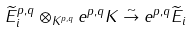Convert formula to latex. <formula><loc_0><loc_0><loc_500><loc_500>\widetilde { E } ^ { p , q } _ { i } \otimes _ { K ^ { p , q } } e ^ { p , q } K \stackrel { \sim } { \rightarrow } e ^ { p , q } \widetilde { E } _ { i }</formula> 